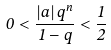Convert formula to latex. <formula><loc_0><loc_0><loc_500><loc_500>0 < \frac { \left | a \right | q ^ { n } } { 1 - q } < \frac { 1 } { 2 }</formula> 